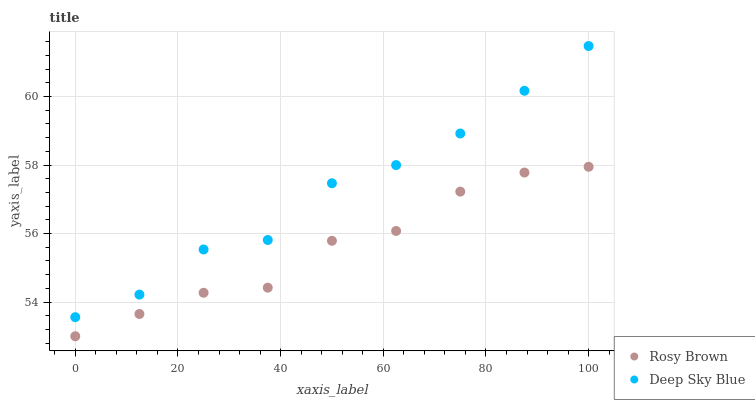Does Rosy Brown have the minimum area under the curve?
Answer yes or no. Yes. Does Deep Sky Blue have the maximum area under the curve?
Answer yes or no. Yes. Does Deep Sky Blue have the minimum area under the curve?
Answer yes or no. No. Is Rosy Brown the smoothest?
Answer yes or no. Yes. Is Deep Sky Blue the roughest?
Answer yes or no. Yes. Is Deep Sky Blue the smoothest?
Answer yes or no. No. Does Rosy Brown have the lowest value?
Answer yes or no. Yes. Does Deep Sky Blue have the lowest value?
Answer yes or no. No. Does Deep Sky Blue have the highest value?
Answer yes or no. Yes. Is Rosy Brown less than Deep Sky Blue?
Answer yes or no. Yes. Is Deep Sky Blue greater than Rosy Brown?
Answer yes or no. Yes. Does Rosy Brown intersect Deep Sky Blue?
Answer yes or no. No. 